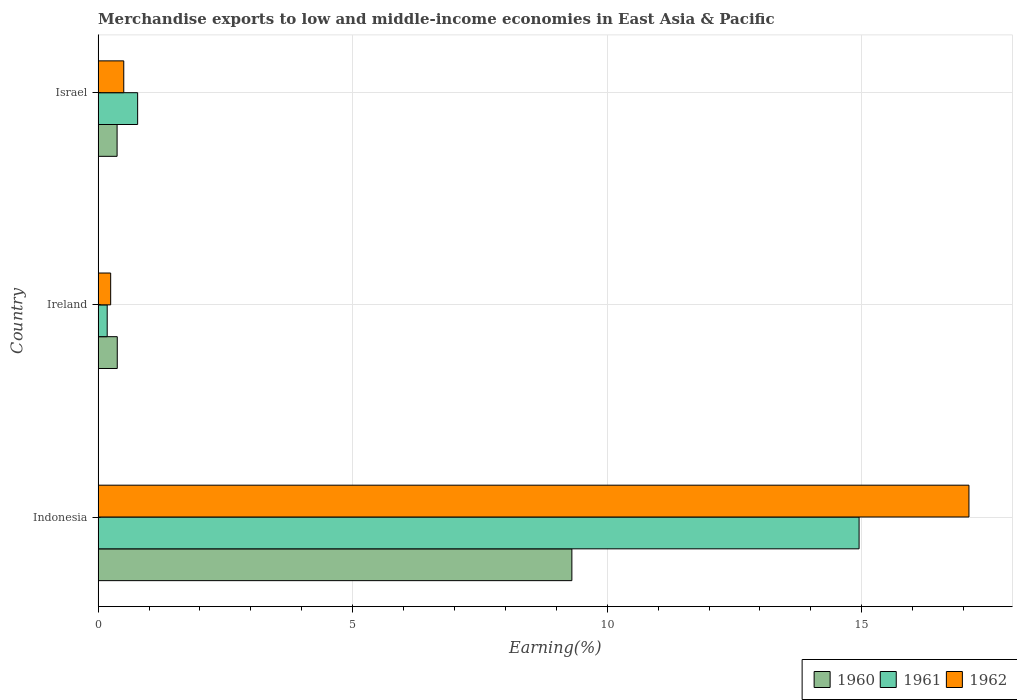How many different coloured bars are there?
Your response must be concise. 3. How many groups of bars are there?
Provide a succinct answer. 3. Are the number of bars per tick equal to the number of legend labels?
Provide a short and direct response. Yes. How many bars are there on the 3rd tick from the bottom?
Your response must be concise. 3. What is the percentage of amount earned from merchandise exports in 1962 in Indonesia?
Give a very brief answer. 17.11. Across all countries, what is the maximum percentage of amount earned from merchandise exports in 1960?
Provide a succinct answer. 9.31. Across all countries, what is the minimum percentage of amount earned from merchandise exports in 1961?
Make the answer very short. 0.18. In which country was the percentage of amount earned from merchandise exports in 1962 minimum?
Your answer should be compact. Ireland. What is the total percentage of amount earned from merchandise exports in 1961 in the graph?
Your answer should be compact. 15.9. What is the difference between the percentage of amount earned from merchandise exports in 1962 in Indonesia and that in Ireland?
Provide a succinct answer. 16.86. What is the difference between the percentage of amount earned from merchandise exports in 1960 in Israel and the percentage of amount earned from merchandise exports in 1962 in Indonesia?
Ensure brevity in your answer.  -16.73. What is the average percentage of amount earned from merchandise exports in 1960 per country?
Your answer should be compact. 3.35. What is the difference between the percentage of amount earned from merchandise exports in 1960 and percentage of amount earned from merchandise exports in 1961 in Israel?
Keep it short and to the point. -0.4. In how many countries, is the percentage of amount earned from merchandise exports in 1960 greater than 14 %?
Your response must be concise. 0. What is the ratio of the percentage of amount earned from merchandise exports in 1962 in Indonesia to that in Ireland?
Make the answer very short. 69.37. Is the difference between the percentage of amount earned from merchandise exports in 1960 in Indonesia and Israel greater than the difference between the percentage of amount earned from merchandise exports in 1961 in Indonesia and Israel?
Your response must be concise. No. What is the difference between the highest and the second highest percentage of amount earned from merchandise exports in 1960?
Make the answer very short. 8.93. What is the difference between the highest and the lowest percentage of amount earned from merchandise exports in 1962?
Provide a short and direct response. 16.86. Is the sum of the percentage of amount earned from merchandise exports in 1961 in Indonesia and Ireland greater than the maximum percentage of amount earned from merchandise exports in 1962 across all countries?
Make the answer very short. No. What does the 3rd bar from the bottom in Ireland represents?
Your answer should be compact. 1962. Are all the bars in the graph horizontal?
Your answer should be compact. Yes. How many countries are there in the graph?
Provide a succinct answer. 3. What is the difference between two consecutive major ticks on the X-axis?
Your answer should be compact. 5. Does the graph contain any zero values?
Offer a very short reply. No. Does the graph contain grids?
Ensure brevity in your answer.  Yes. How many legend labels are there?
Give a very brief answer. 3. How are the legend labels stacked?
Offer a terse response. Horizontal. What is the title of the graph?
Provide a short and direct response. Merchandise exports to low and middle-income economies in East Asia & Pacific. What is the label or title of the X-axis?
Your response must be concise. Earning(%). What is the label or title of the Y-axis?
Your answer should be compact. Country. What is the Earning(%) of 1960 in Indonesia?
Your answer should be compact. 9.31. What is the Earning(%) in 1961 in Indonesia?
Your response must be concise. 14.95. What is the Earning(%) of 1962 in Indonesia?
Offer a terse response. 17.11. What is the Earning(%) in 1960 in Ireland?
Provide a succinct answer. 0.38. What is the Earning(%) in 1961 in Ireland?
Give a very brief answer. 0.18. What is the Earning(%) in 1962 in Ireland?
Offer a very short reply. 0.25. What is the Earning(%) in 1960 in Israel?
Give a very brief answer. 0.37. What is the Earning(%) of 1961 in Israel?
Give a very brief answer. 0.78. What is the Earning(%) of 1962 in Israel?
Keep it short and to the point. 0.5. Across all countries, what is the maximum Earning(%) in 1960?
Make the answer very short. 9.31. Across all countries, what is the maximum Earning(%) in 1961?
Your answer should be compact. 14.95. Across all countries, what is the maximum Earning(%) in 1962?
Offer a terse response. 17.11. Across all countries, what is the minimum Earning(%) in 1960?
Offer a terse response. 0.37. Across all countries, what is the minimum Earning(%) of 1961?
Offer a very short reply. 0.18. Across all countries, what is the minimum Earning(%) of 1962?
Offer a terse response. 0.25. What is the total Earning(%) in 1960 in the graph?
Ensure brevity in your answer.  10.06. What is the total Earning(%) of 1961 in the graph?
Ensure brevity in your answer.  15.9. What is the total Earning(%) in 1962 in the graph?
Make the answer very short. 17.86. What is the difference between the Earning(%) in 1960 in Indonesia and that in Ireland?
Your answer should be very brief. 8.93. What is the difference between the Earning(%) in 1961 in Indonesia and that in Ireland?
Offer a very short reply. 14.77. What is the difference between the Earning(%) of 1962 in Indonesia and that in Ireland?
Offer a terse response. 16.86. What is the difference between the Earning(%) of 1960 in Indonesia and that in Israel?
Your response must be concise. 8.93. What is the difference between the Earning(%) of 1961 in Indonesia and that in Israel?
Keep it short and to the point. 14.17. What is the difference between the Earning(%) of 1962 in Indonesia and that in Israel?
Ensure brevity in your answer.  16.6. What is the difference between the Earning(%) in 1960 in Ireland and that in Israel?
Offer a very short reply. 0. What is the difference between the Earning(%) of 1961 in Ireland and that in Israel?
Your answer should be compact. -0.6. What is the difference between the Earning(%) in 1962 in Ireland and that in Israel?
Provide a succinct answer. -0.26. What is the difference between the Earning(%) in 1960 in Indonesia and the Earning(%) in 1961 in Ireland?
Your answer should be very brief. 9.13. What is the difference between the Earning(%) in 1960 in Indonesia and the Earning(%) in 1962 in Ireland?
Ensure brevity in your answer.  9.06. What is the difference between the Earning(%) of 1961 in Indonesia and the Earning(%) of 1962 in Ireland?
Provide a short and direct response. 14.7. What is the difference between the Earning(%) in 1960 in Indonesia and the Earning(%) in 1961 in Israel?
Give a very brief answer. 8.53. What is the difference between the Earning(%) of 1960 in Indonesia and the Earning(%) of 1962 in Israel?
Give a very brief answer. 8.8. What is the difference between the Earning(%) of 1961 in Indonesia and the Earning(%) of 1962 in Israel?
Offer a very short reply. 14.44. What is the difference between the Earning(%) in 1960 in Ireland and the Earning(%) in 1961 in Israel?
Make the answer very short. -0.4. What is the difference between the Earning(%) of 1960 in Ireland and the Earning(%) of 1962 in Israel?
Provide a succinct answer. -0.13. What is the difference between the Earning(%) of 1961 in Ireland and the Earning(%) of 1962 in Israel?
Provide a short and direct response. -0.33. What is the average Earning(%) in 1960 per country?
Make the answer very short. 3.35. What is the average Earning(%) of 1961 per country?
Give a very brief answer. 5.3. What is the average Earning(%) of 1962 per country?
Offer a terse response. 5.95. What is the difference between the Earning(%) of 1960 and Earning(%) of 1961 in Indonesia?
Give a very brief answer. -5.64. What is the difference between the Earning(%) in 1960 and Earning(%) in 1962 in Indonesia?
Offer a terse response. -7.8. What is the difference between the Earning(%) of 1961 and Earning(%) of 1962 in Indonesia?
Your answer should be very brief. -2.16. What is the difference between the Earning(%) in 1960 and Earning(%) in 1961 in Ireland?
Offer a very short reply. 0.2. What is the difference between the Earning(%) of 1960 and Earning(%) of 1962 in Ireland?
Offer a very short reply. 0.13. What is the difference between the Earning(%) of 1961 and Earning(%) of 1962 in Ireland?
Make the answer very short. -0.07. What is the difference between the Earning(%) of 1960 and Earning(%) of 1961 in Israel?
Your response must be concise. -0.4. What is the difference between the Earning(%) in 1960 and Earning(%) in 1962 in Israel?
Offer a very short reply. -0.13. What is the difference between the Earning(%) of 1961 and Earning(%) of 1962 in Israel?
Provide a succinct answer. 0.27. What is the ratio of the Earning(%) of 1960 in Indonesia to that in Ireland?
Your answer should be compact. 24.74. What is the ratio of the Earning(%) in 1961 in Indonesia to that in Ireland?
Your answer should be compact. 83.74. What is the ratio of the Earning(%) in 1962 in Indonesia to that in Ireland?
Offer a terse response. 69.36. What is the ratio of the Earning(%) in 1960 in Indonesia to that in Israel?
Ensure brevity in your answer.  24.96. What is the ratio of the Earning(%) of 1961 in Indonesia to that in Israel?
Your answer should be compact. 19.25. What is the ratio of the Earning(%) in 1962 in Indonesia to that in Israel?
Provide a succinct answer. 33.94. What is the ratio of the Earning(%) in 1960 in Ireland to that in Israel?
Make the answer very short. 1.01. What is the ratio of the Earning(%) of 1961 in Ireland to that in Israel?
Your response must be concise. 0.23. What is the ratio of the Earning(%) in 1962 in Ireland to that in Israel?
Provide a short and direct response. 0.49. What is the difference between the highest and the second highest Earning(%) of 1960?
Make the answer very short. 8.93. What is the difference between the highest and the second highest Earning(%) of 1961?
Offer a terse response. 14.17. What is the difference between the highest and the second highest Earning(%) of 1962?
Provide a short and direct response. 16.6. What is the difference between the highest and the lowest Earning(%) of 1960?
Your answer should be very brief. 8.93. What is the difference between the highest and the lowest Earning(%) of 1961?
Your response must be concise. 14.77. What is the difference between the highest and the lowest Earning(%) in 1962?
Keep it short and to the point. 16.86. 